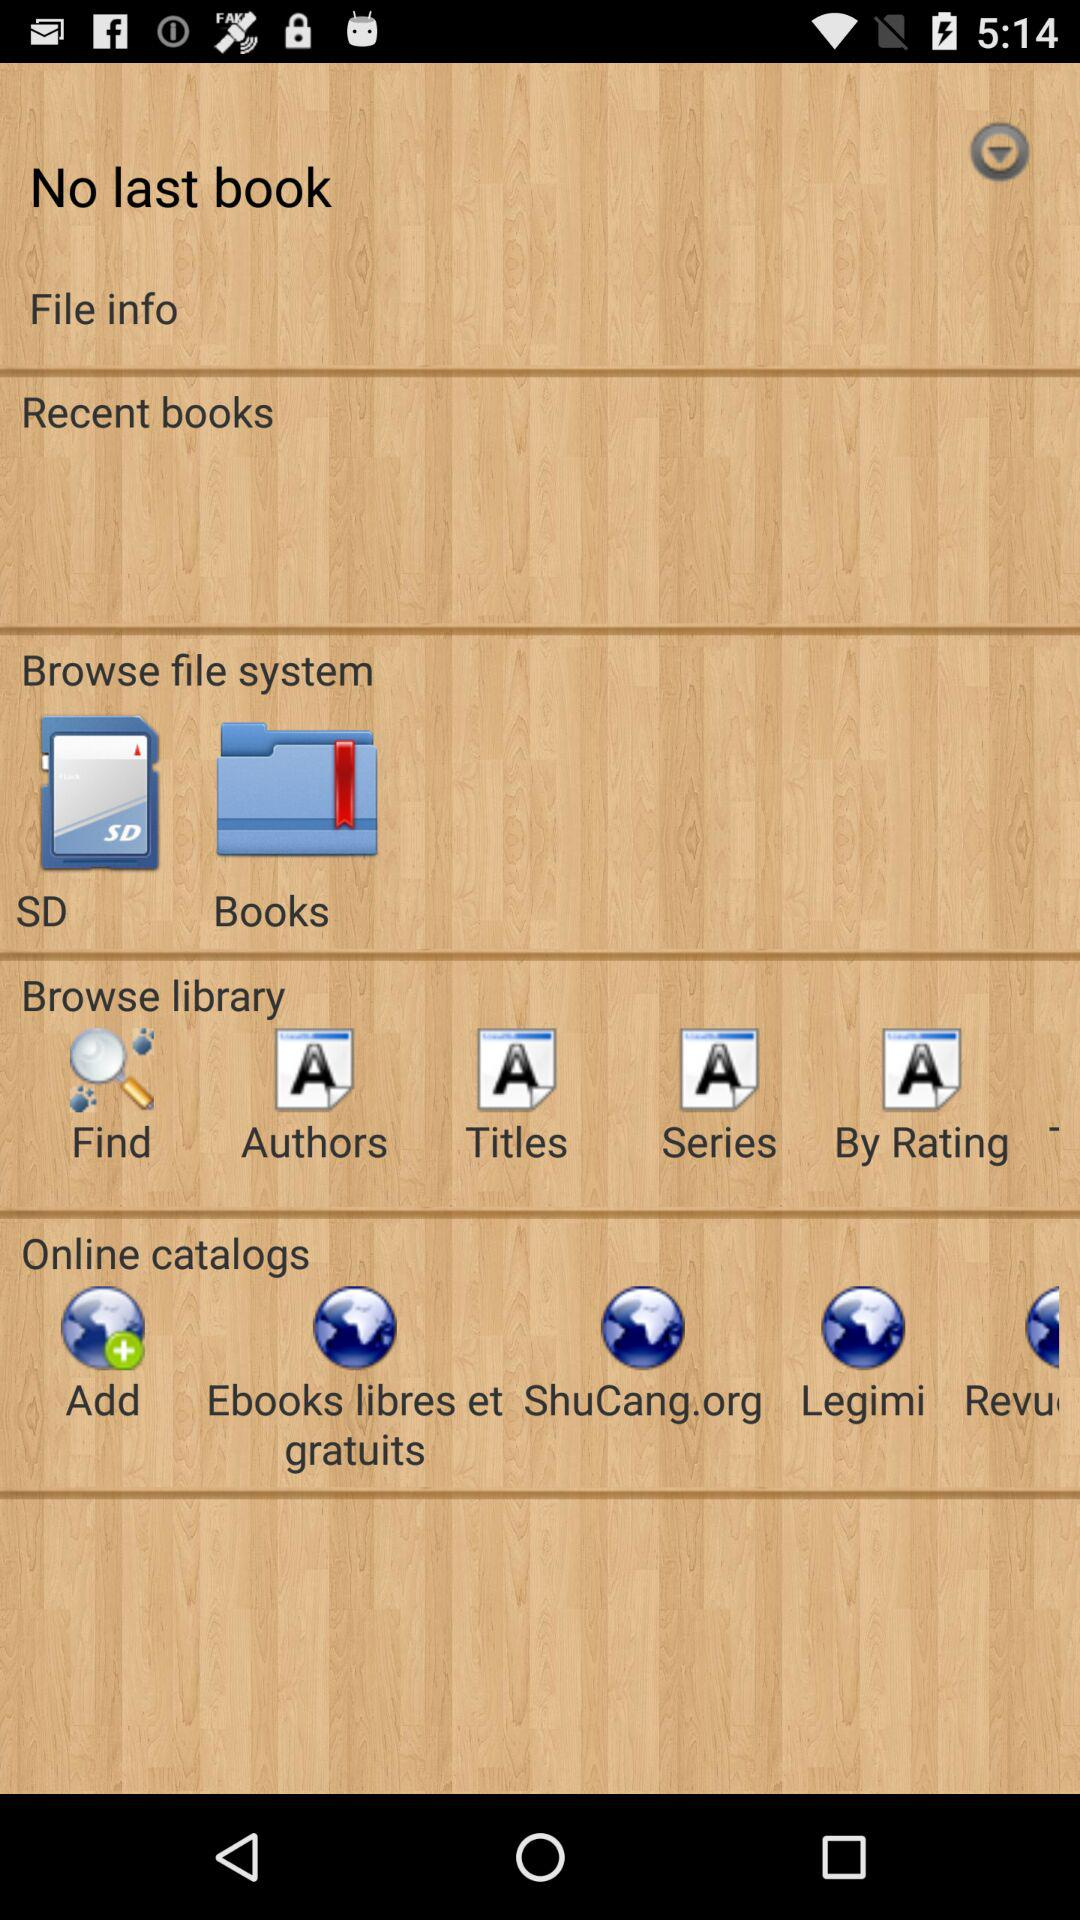Is there any last book? There is no last book. 